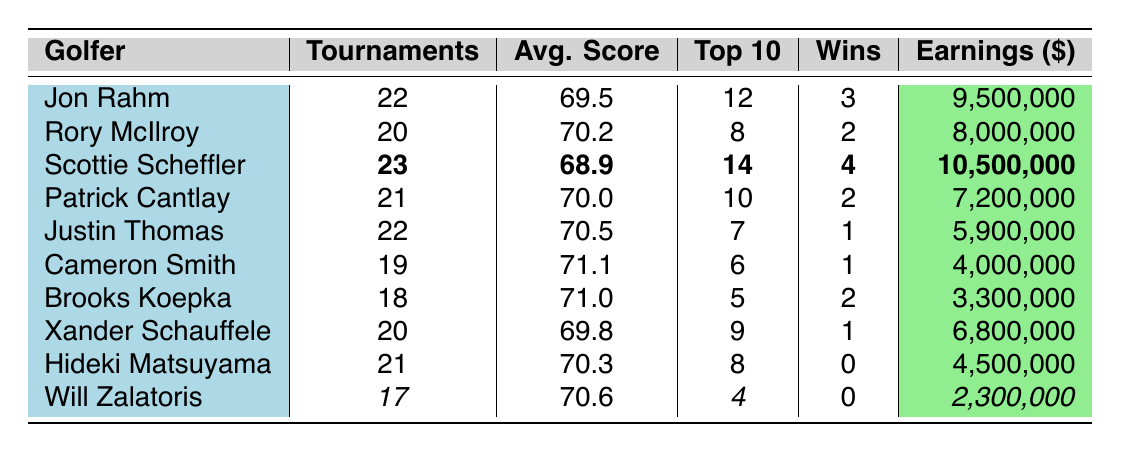What is the highest average score recorded among the golfers? The average scores are listed next to each golfer, and the highest value among them is 71.1, which belongs to Cameron Smith.
Answer: 71.1 How many tournaments did Scottie Scheffler participate in? The table shows that Scottie Scheffler played 23 tournaments, making him the golfer with the highest participation.
Answer: 23 Who had the most wins in 2023? By comparing the 'Wins' column, Scottie Scheffler has the most wins with a total of 4 wins.
Answer: Scottie Scheffler What is the total earnings of Patrick Cantlay and Justin Thomas combined? Patrick Cantlay earned $7,200,000 and Justin Thomas earned $5,900,000. Adding these gives $7,200,000 + $5,900,000 = $13,100,000.
Answer: 13,100,000 Did Hideki Matsuyama achieve any wins in 2023? The 'Wins' column shows that Hideki Matsuyama recorded 0 wins, indicating he did not win any tournaments this year.
Answer: No What is the average score of the top 10 finishers for Jon Rahm? Jon Rahm's data indicates 12 top 10 finishes, alongside his average score of 69.5. However, the average score does not directly correlate with top 10 finishes, as scores are individual; thus, his average remains 69.5.
Answer: 69.5 Which golfer played the least number of tournaments? Looking through the 'Tournaments' column, Will Zalatoris participated in 17 tournaments, which is the least among all listed golfers.
Answer: Will Zalatoris What is the difference in earnings between Scottie Scheffler and Jon Rahm? Scottie Scheffler earned $10,500,000 and Jon Rahm earned $9,500,000. The difference is $10,500,000 - $9,500,000 = $1,000,000.
Answer: 1,000,000 Which golfer has the highest percentage of top 10 finishes based on tournaments played? To find the percentage, divide the top 10 finishes by tournaments played and multiply by 100. For Jon Rahm: (12/22) * 100 ≈ 54.55%. For Scottie Scheffler: (14/23) * 100 ≈ 60.87%. Scheffler has the highest percentage at 60.87%.
Answer: Scottie Scheffler If you were to rank golfers by earnings, who would come fifth? The earnings sorted in descending order are: Scheffler, Rahm, McIlroy, Cantlay, and then Thomas (with $5,900,000). Thus, the fifth-ranking golfer based on earnings is Justin Thomas.
Answer: Justin Thomas 